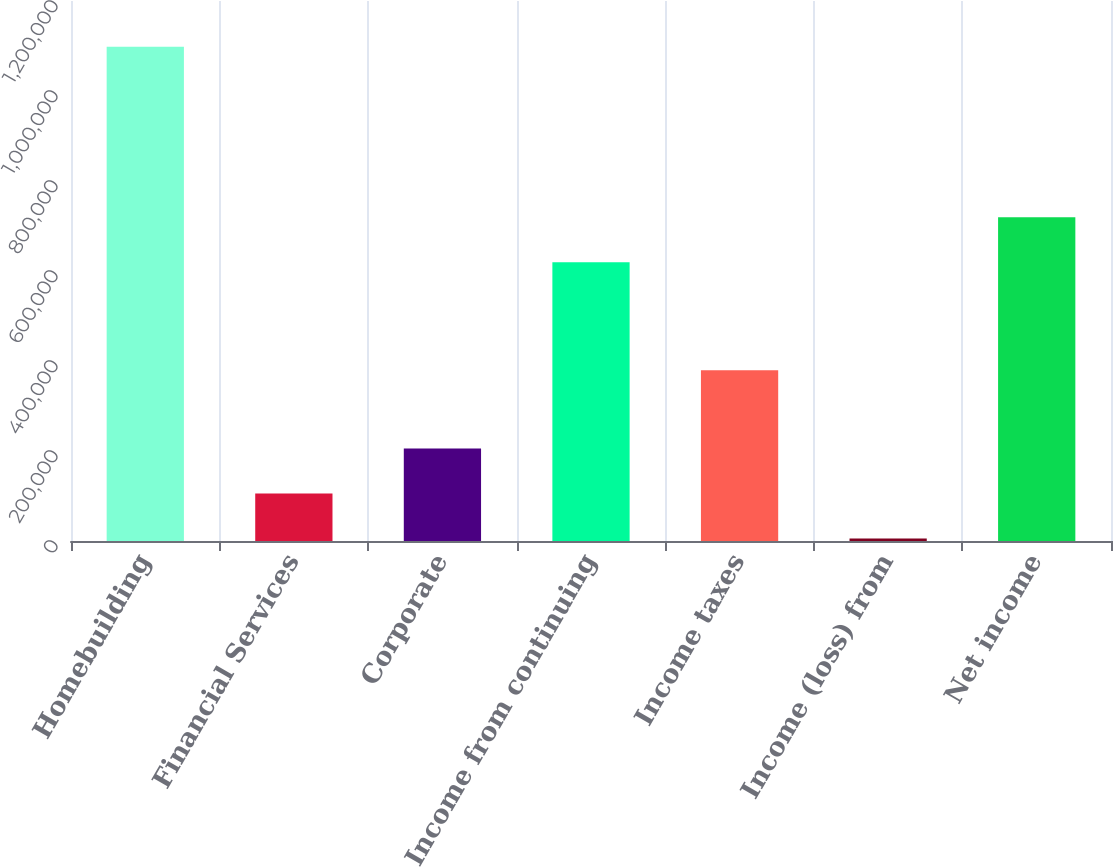Convert chart to OTSL. <chart><loc_0><loc_0><loc_500><loc_500><bar_chart><fcel>Homebuilding<fcel>Financial Services<fcel>Corporate<fcel>Income from continuing<fcel>Income taxes<fcel>Income (loss) from<fcel>Net income<nl><fcel>1.09859e+06<fcel>105364<fcel>205338<fcel>619243<fcel>379376<fcel>5391<fcel>719216<nl></chart> 